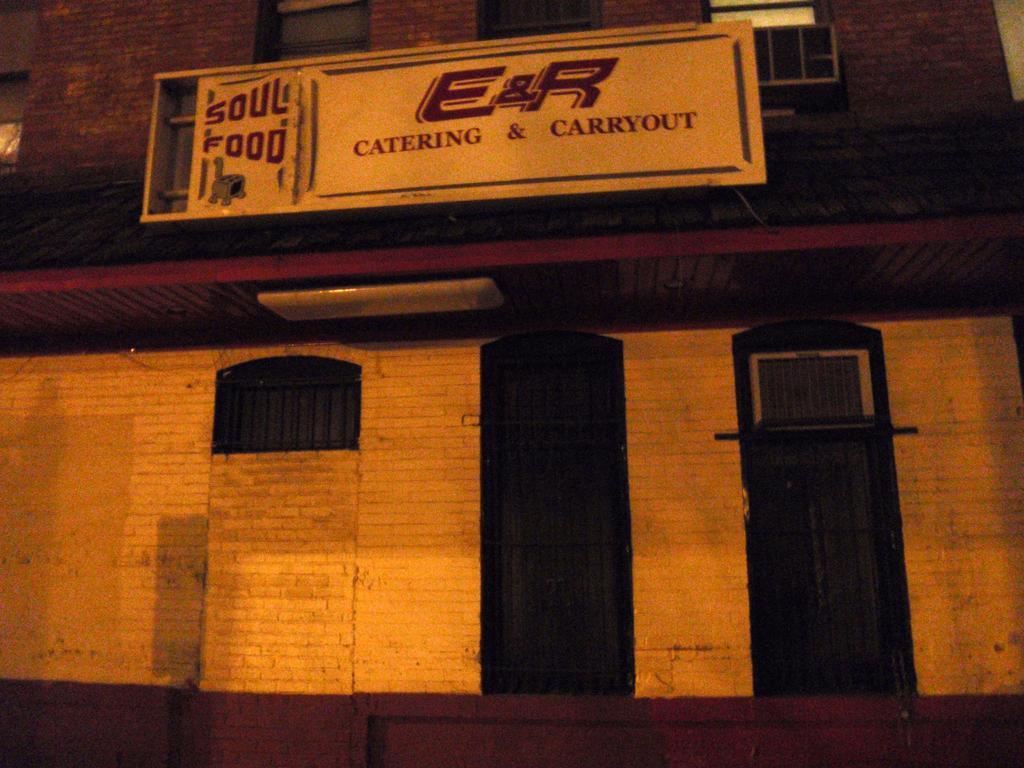How would you summarize this image in a sentence or two? In this image in the center there is one building and some doors and one board, and on the board there is text. 